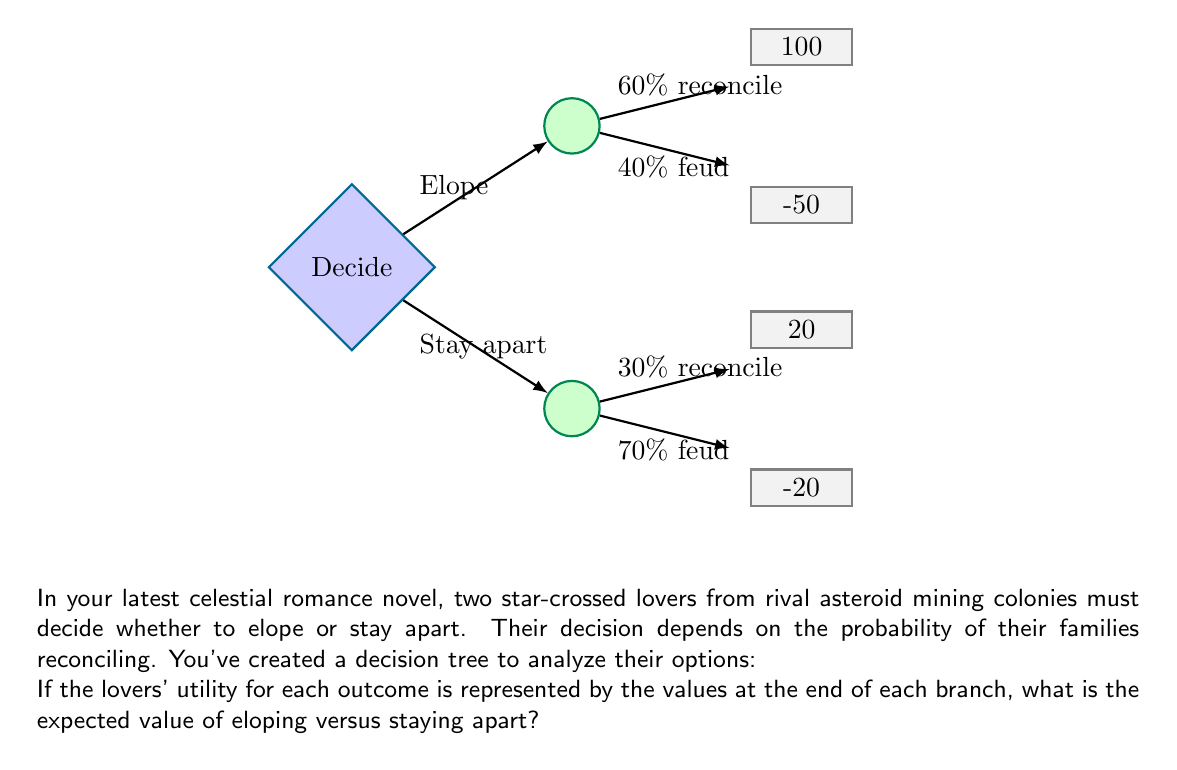Can you answer this question? Let's approach this step-by-step using decision theory and expected value calculations:

1) First, let's calculate the expected value of eloping:

   Eloping has two possible outcomes:
   - 60% chance of families reconciling: 100 utility
   - 40% chance of continued feud: -50 utility

   Expected Value of Eloping (EVE):
   $$EVE = 0.60 \times 100 + 0.40 \times (-50) = 60 - 20 = 40$$

2) Now, let's calculate the expected value of staying apart:

   Staying apart also has two possible outcomes:
   - 30% chance of families reconciling: 20 utility
   - 70% chance of continued feud: -20 utility

   Expected Value of Staying Apart (EVS):
   $$EVS = 0.30 \times 20 + 0.70 \times (-20) = 6 - 14 = -8$$

3) Compare the two expected values:
   - Eloping: 40
   - Staying Apart: -8

The expected value of eloping (40) is higher than the expected value of staying apart (-8).
Answer: Eloping: 40, Staying Apart: -8 